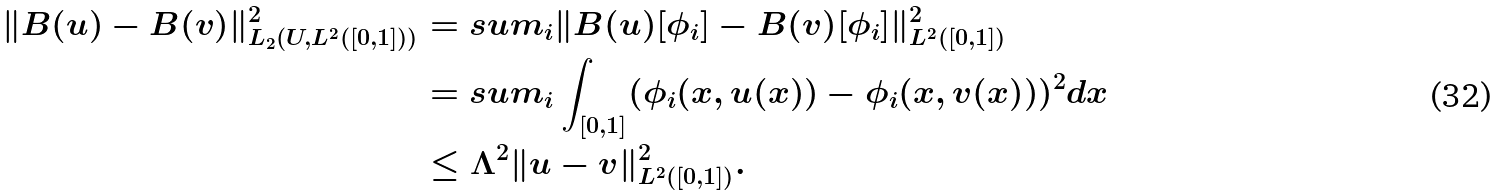Convert formula to latex. <formula><loc_0><loc_0><loc_500><loc_500>\| B ( u ) - B ( v ) \| _ { L _ { 2 } ( U , L ^ { 2 } ( [ 0 , 1 ] ) ) } ^ { 2 } & = s u m _ { i } \| B ( u ) [ \phi _ { i } ] - B ( v ) [ \phi _ { i } ] \| _ { L ^ { 2 } ( [ 0 , 1 ] ) } ^ { 2 } \\ & = s u m _ { i } \int _ { [ 0 , 1 ] } ( \phi _ { i } ( x , u ( x ) ) - \phi _ { i } ( x , v ( x ) ) ) ^ { 2 } d x \\ & \leq \Lambda ^ { 2 } \| u - v \| _ { L ^ { 2 } ( [ 0 , 1 ] ) } ^ { 2 } .</formula> 